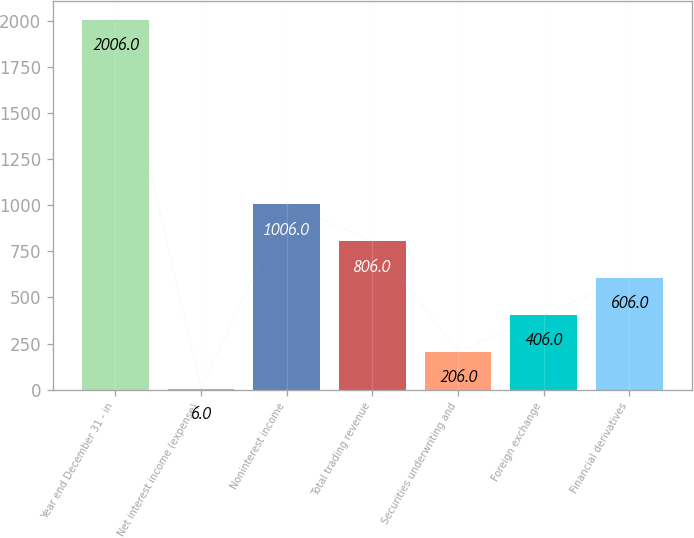Convert chart to OTSL. <chart><loc_0><loc_0><loc_500><loc_500><bar_chart><fcel>Year end December 31 - in<fcel>Net interest income (expense)<fcel>Noninterest income<fcel>Total trading revenue<fcel>Securities underwriting and<fcel>Foreign exchange<fcel>Financial derivatives<nl><fcel>2006<fcel>6<fcel>1006<fcel>806<fcel>206<fcel>406<fcel>606<nl></chart> 